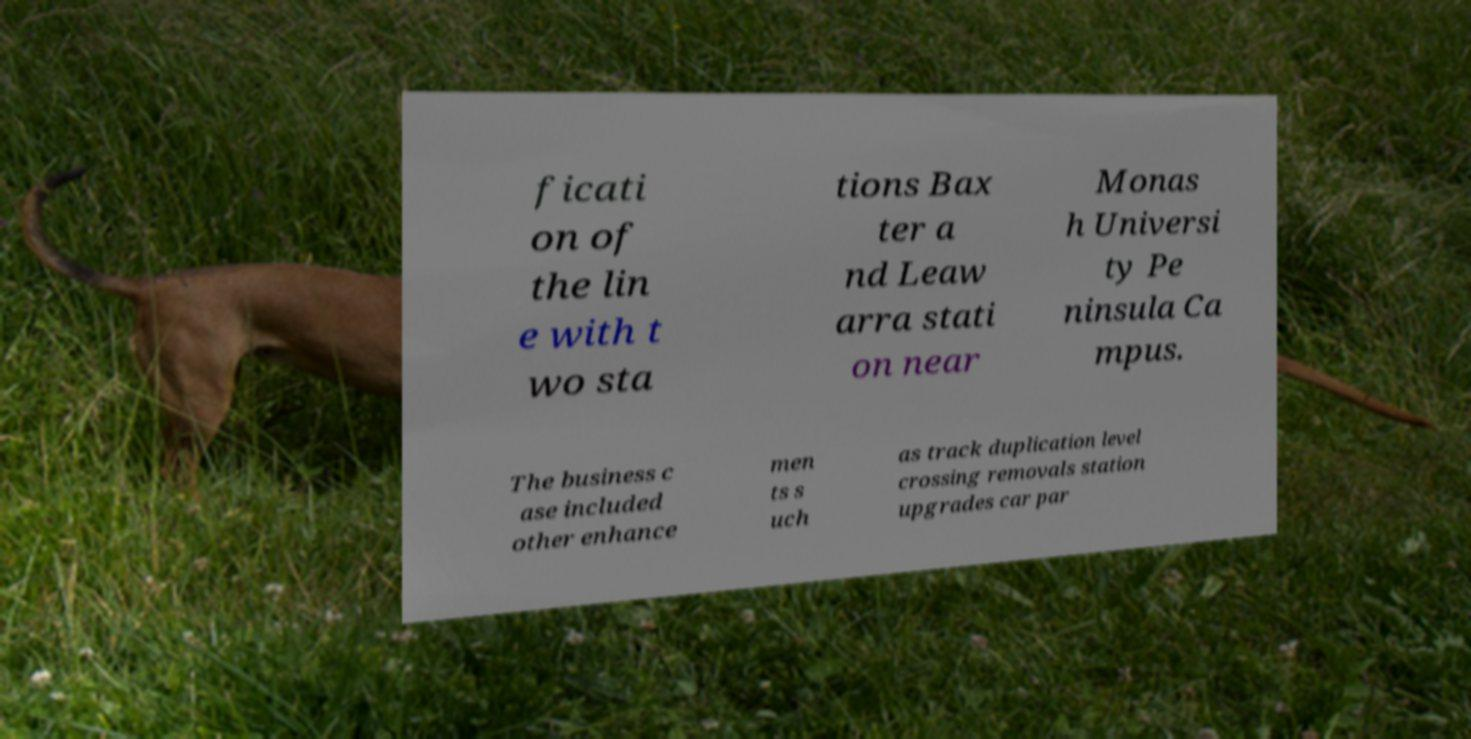Can you read and provide the text displayed in the image?This photo seems to have some interesting text. Can you extract and type it out for me? ficati on of the lin e with t wo sta tions Bax ter a nd Leaw arra stati on near Monas h Universi ty Pe ninsula Ca mpus. The business c ase included other enhance men ts s uch as track duplication level crossing removals station upgrades car par 